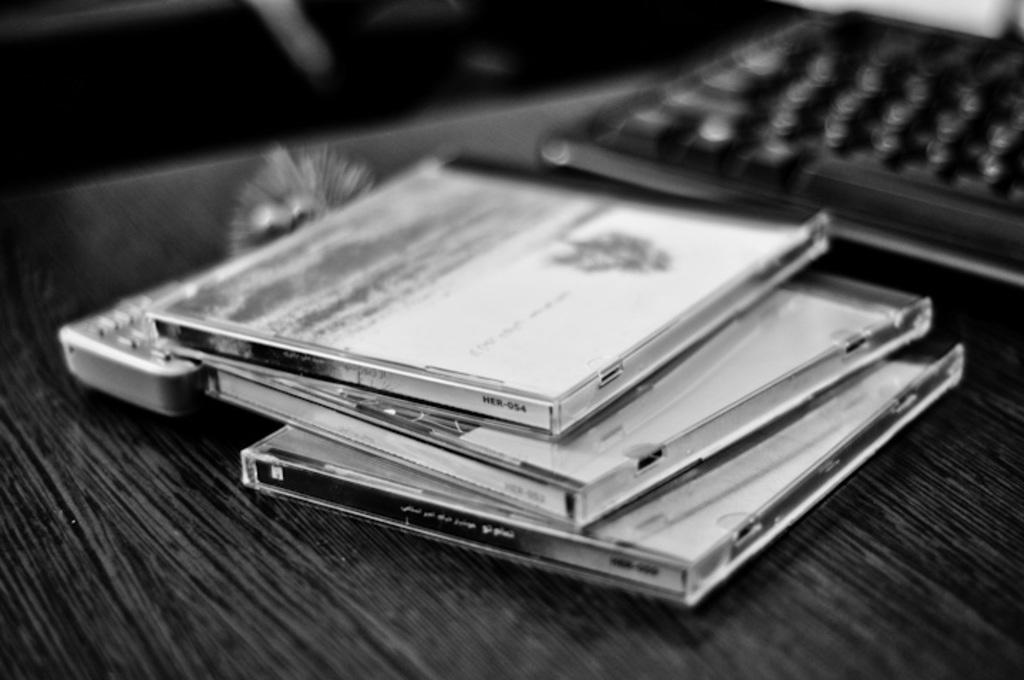<image>
Provide a brief description of the given image. the number 4 is on the side of one of the cd's 